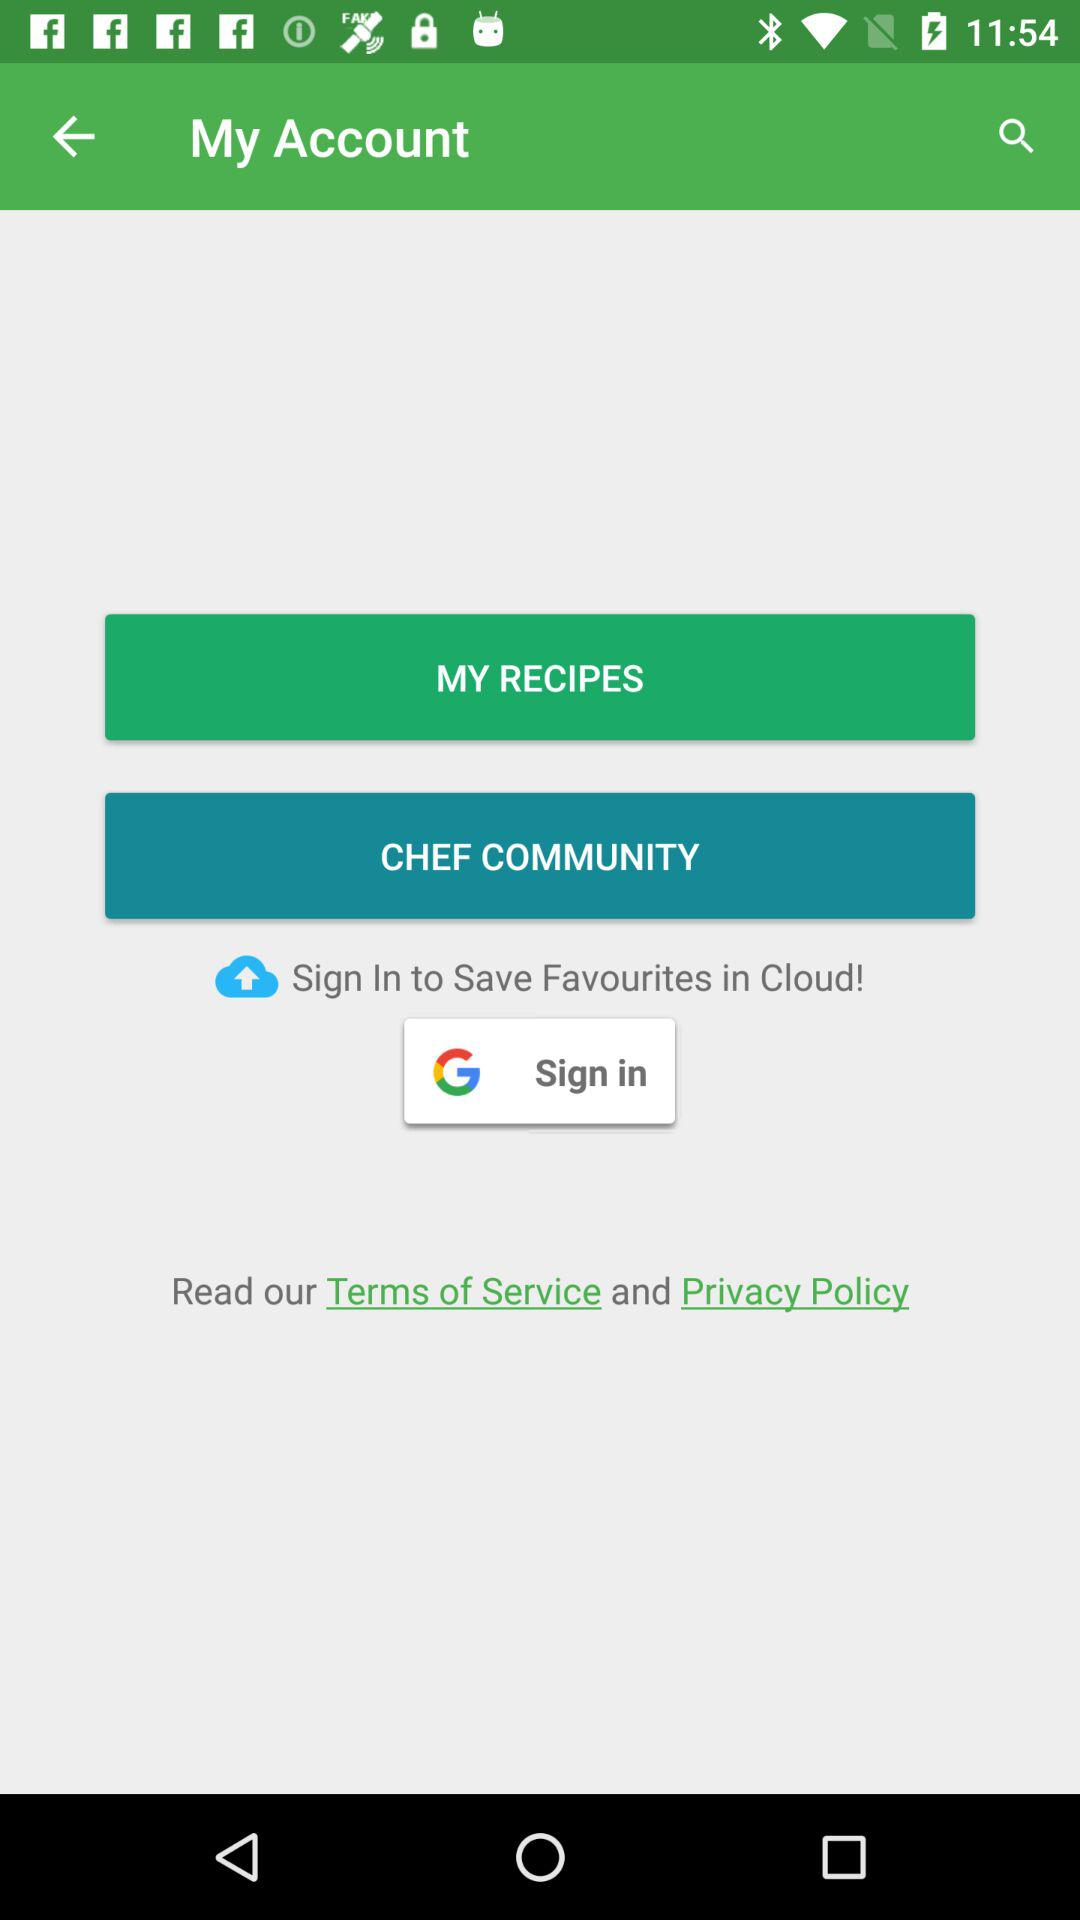What account can be used to sign in? The account that can be used to sign in is "Google". 